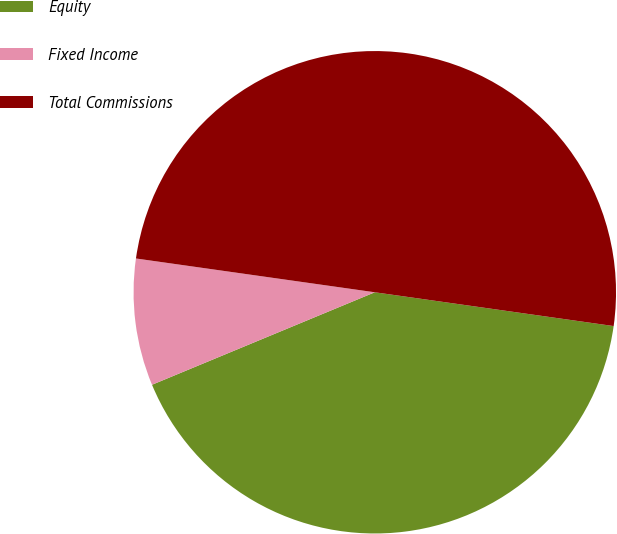Convert chart. <chart><loc_0><loc_0><loc_500><loc_500><pie_chart><fcel>Equity<fcel>Fixed Income<fcel>Total Commissions<nl><fcel>41.5%<fcel>8.5%<fcel>50.0%<nl></chart> 